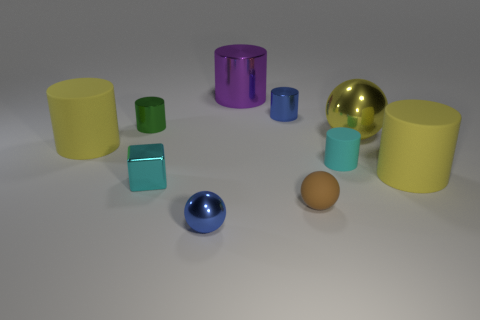Subtract all cyan cylinders. How many cylinders are left? 5 Subtract all tiny blue metal cylinders. How many cylinders are left? 5 Subtract 1 cylinders. How many cylinders are left? 5 Subtract all green cylinders. Subtract all red balls. How many cylinders are left? 5 Subtract all spheres. How many objects are left? 7 Subtract 0 purple blocks. How many objects are left? 10 Subtract all large rubber objects. Subtract all matte spheres. How many objects are left? 7 Add 6 green cylinders. How many green cylinders are left? 7 Add 7 brown rubber spheres. How many brown rubber spheres exist? 8 